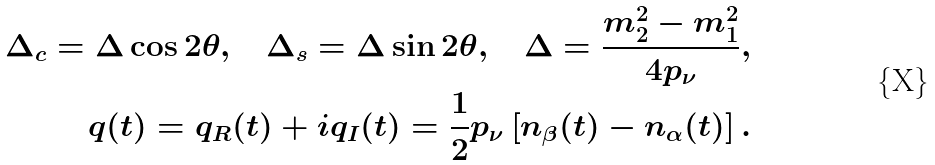Convert formula to latex. <formula><loc_0><loc_0><loc_500><loc_500>\Delta _ { c } = \Delta \cos 2 \theta , \quad \Delta _ { s } = \Delta \sin 2 \theta , \quad \Delta = \frac { m _ { 2 } ^ { 2 } - m _ { 1 } ^ { 2 } } { 4 p _ { \nu } } , \\ q ( t ) = q _ { R } ( t ) + i q _ { I } ( t ) = \frac { 1 } { 2 } p _ { \nu } \left [ n _ { \beta } ( t ) - n _ { \alpha } ( t ) \right ] .</formula> 